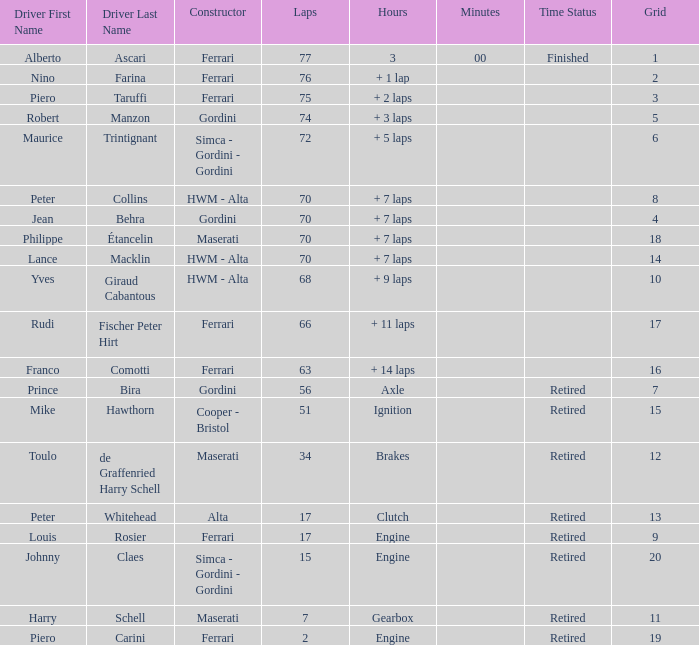What is the high grid for ferrari's with 2 laps? 19.0. 